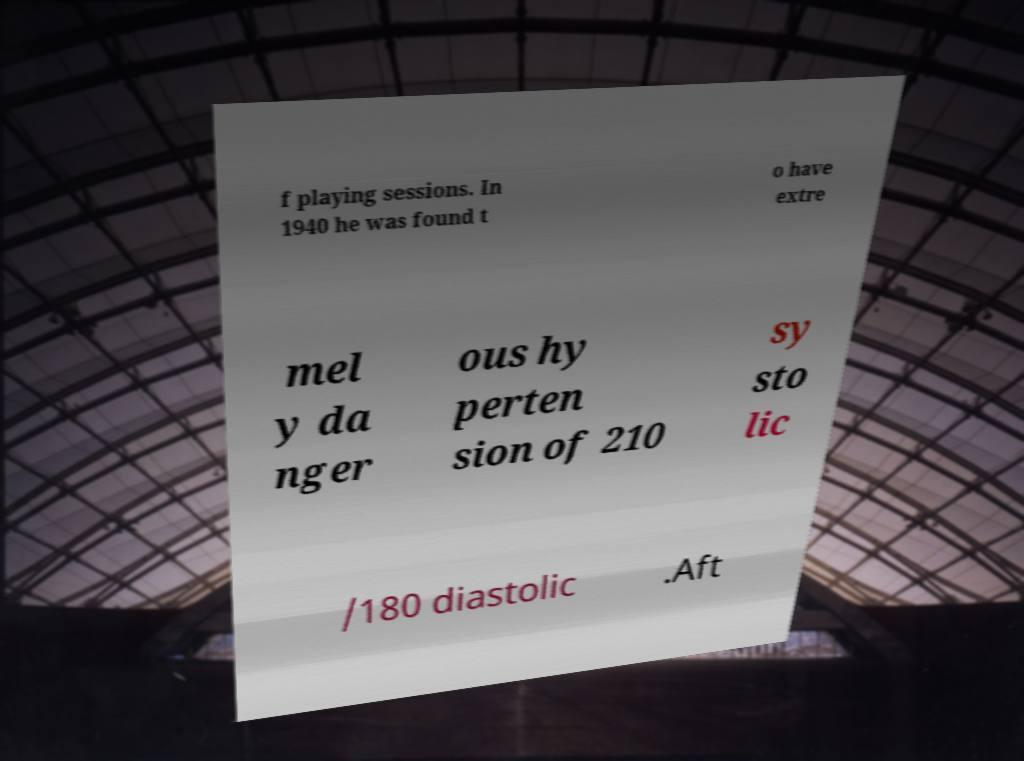Can you read and provide the text displayed in the image?This photo seems to have some interesting text. Can you extract and type it out for me? f playing sessions. In 1940 he was found t o have extre mel y da nger ous hy perten sion of 210 sy sto lic /180 diastolic .Aft 